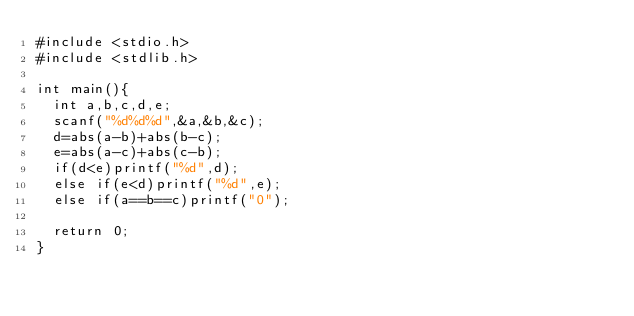Convert code to text. <code><loc_0><loc_0><loc_500><loc_500><_C_>#include <stdio.h>
#include <stdlib.h>

int main(){
  int a,b,c,d,e;
  scanf("%d%d%d",&a,&b,&c);
  d=abs(a-b)+abs(b-c);
  e=abs(a-c)+abs(c-b);
  if(d<e)printf("%d",d);
  else if(e<d)printf("%d",e);
  else if(a==b==c)printf("0");
  
  return 0;
}</code> 